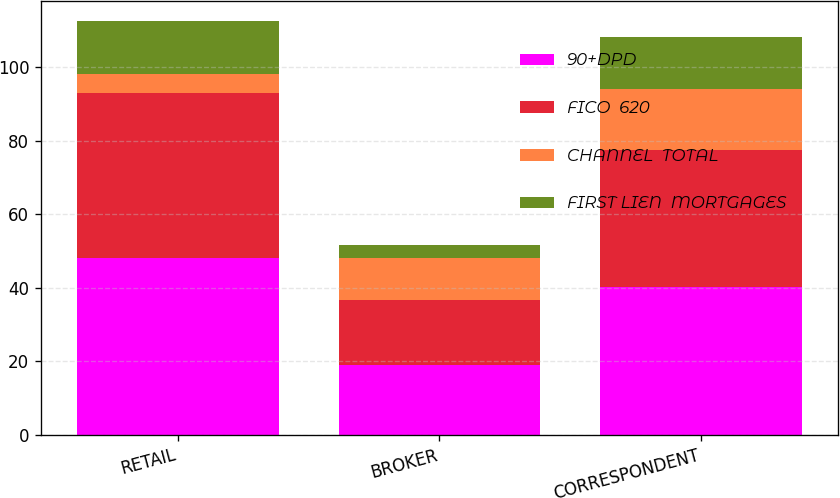Convert chart. <chart><loc_0><loc_0><loc_500><loc_500><stacked_bar_chart><ecel><fcel>RETAIL<fcel>BROKER<fcel>CORRESPONDENT<nl><fcel>90+DPD<fcel>48.2<fcel>19<fcel>40.1<nl><fcel>FICO  620<fcel>44.9<fcel>17.7<fcel>37.4<nl><fcel>CHANNEL  TOTAL<fcel>5.1<fcel>11.3<fcel>16.6<nl><fcel>FIRST LIEN  MORTGAGES<fcel>14.3<fcel>3.7<fcel>14<nl></chart> 